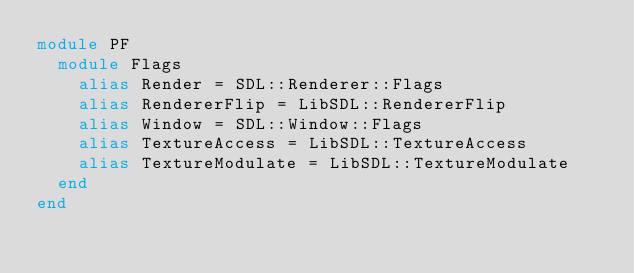Convert code to text. <code><loc_0><loc_0><loc_500><loc_500><_Crystal_>module PF
  module Flags
    alias Render = SDL::Renderer::Flags
    alias RendererFlip = LibSDL::RendererFlip
    alias Window = SDL::Window::Flags
    alias TextureAccess = LibSDL::TextureAccess
    alias TextureModulate = LibSDL::TextureModulate
  end
end
</code> 